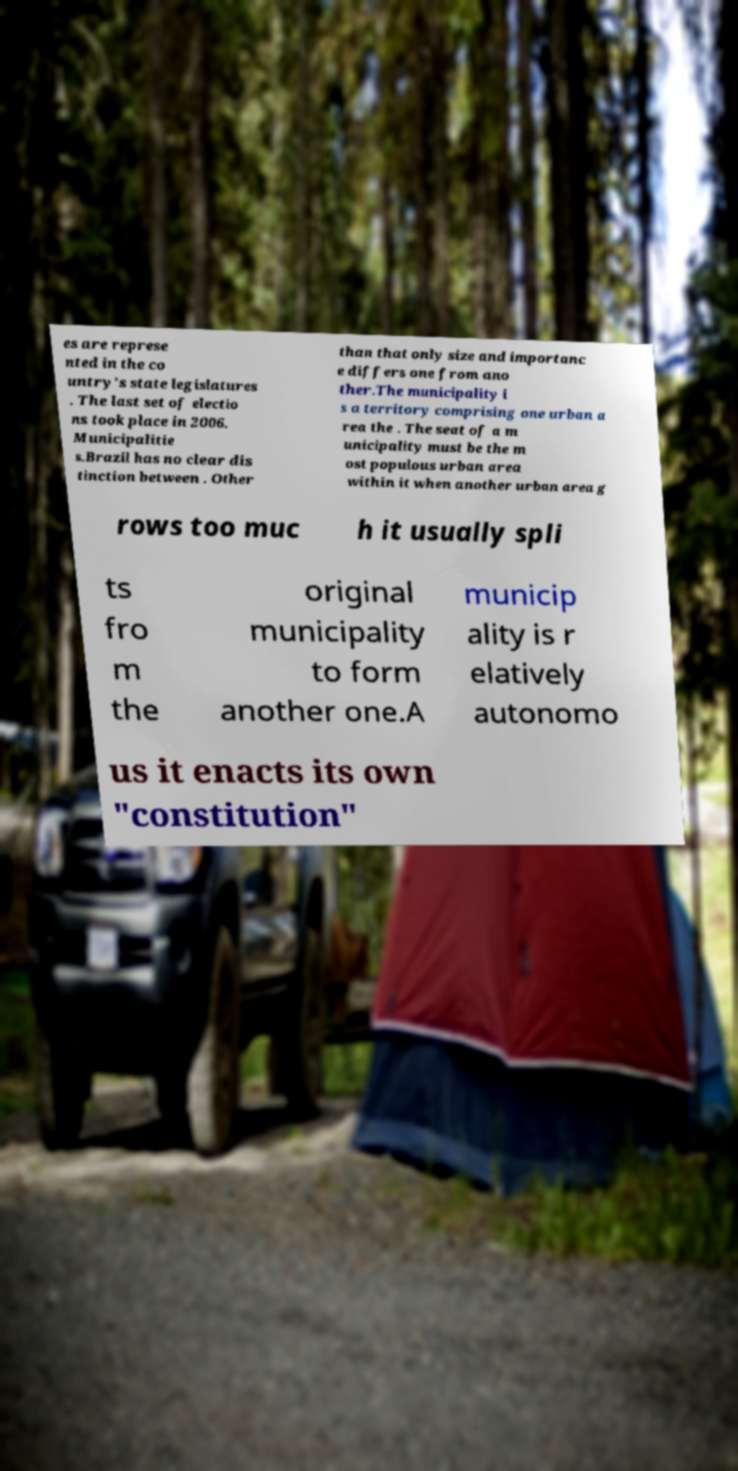Please identify and transcribe the text found in this image. es are represe nted in the co untry's state legislatures . The last set of electio ns took place in 2006. Municipalitie s.Brazil has no clear dis tinction between . Other than that only size and importanc e differs one from ano ther.The municipality i s a territory comprising one urban a rea the . The seat of a m unicipality must be the m ost populous urban area within it when another urban area g rows too muc h it usually spli ts fro m the original municipality to form another one.A municip ality is r elatively autonomo us it enacts its own "constitution" 